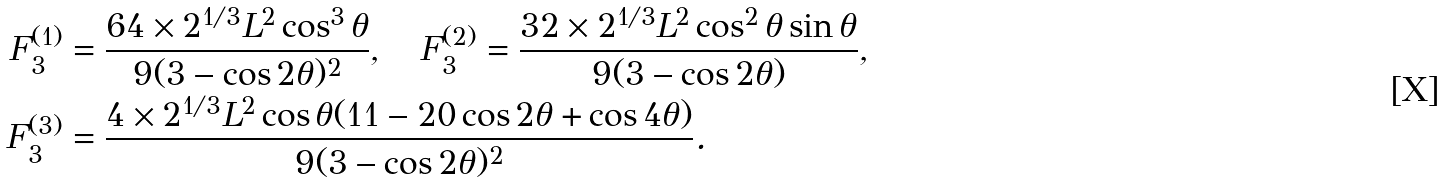Convert formula to latex. <formula><loc_0><loc_0><loc_500><loc_500>F _ { 3 } ^ { ( 1 ) } & = \frac { 6 4 \times 2 ^ { 1 / 3 } L ^ { 2 } \cos ^ { 3 } \theta } { 9 ( 3 - \cos 2 \theta ) ^ { 2 } } , \quad F _ { 3 } ^ { ( 2 ) } = \frac { 3 2 \times 2 ^ { 1 / 3 } L ^ { 2 } \cos ^ { 2 } \theta \sin \theta } { 9 ( 3 - \cos 2 \theta ) } , \\ F _ { 3 } ^ { ( 3 ) } & = \frac { 4 \times 2 ^ { 1 / 3 } L ^ { 2 } \cos \theta ( 1 1 - 2 0 \cos 2 \theta + \cos 4 \theta ) } { 9 ( 3 - \cos 2 \theta ) ^ { 2 } } .</formula> 